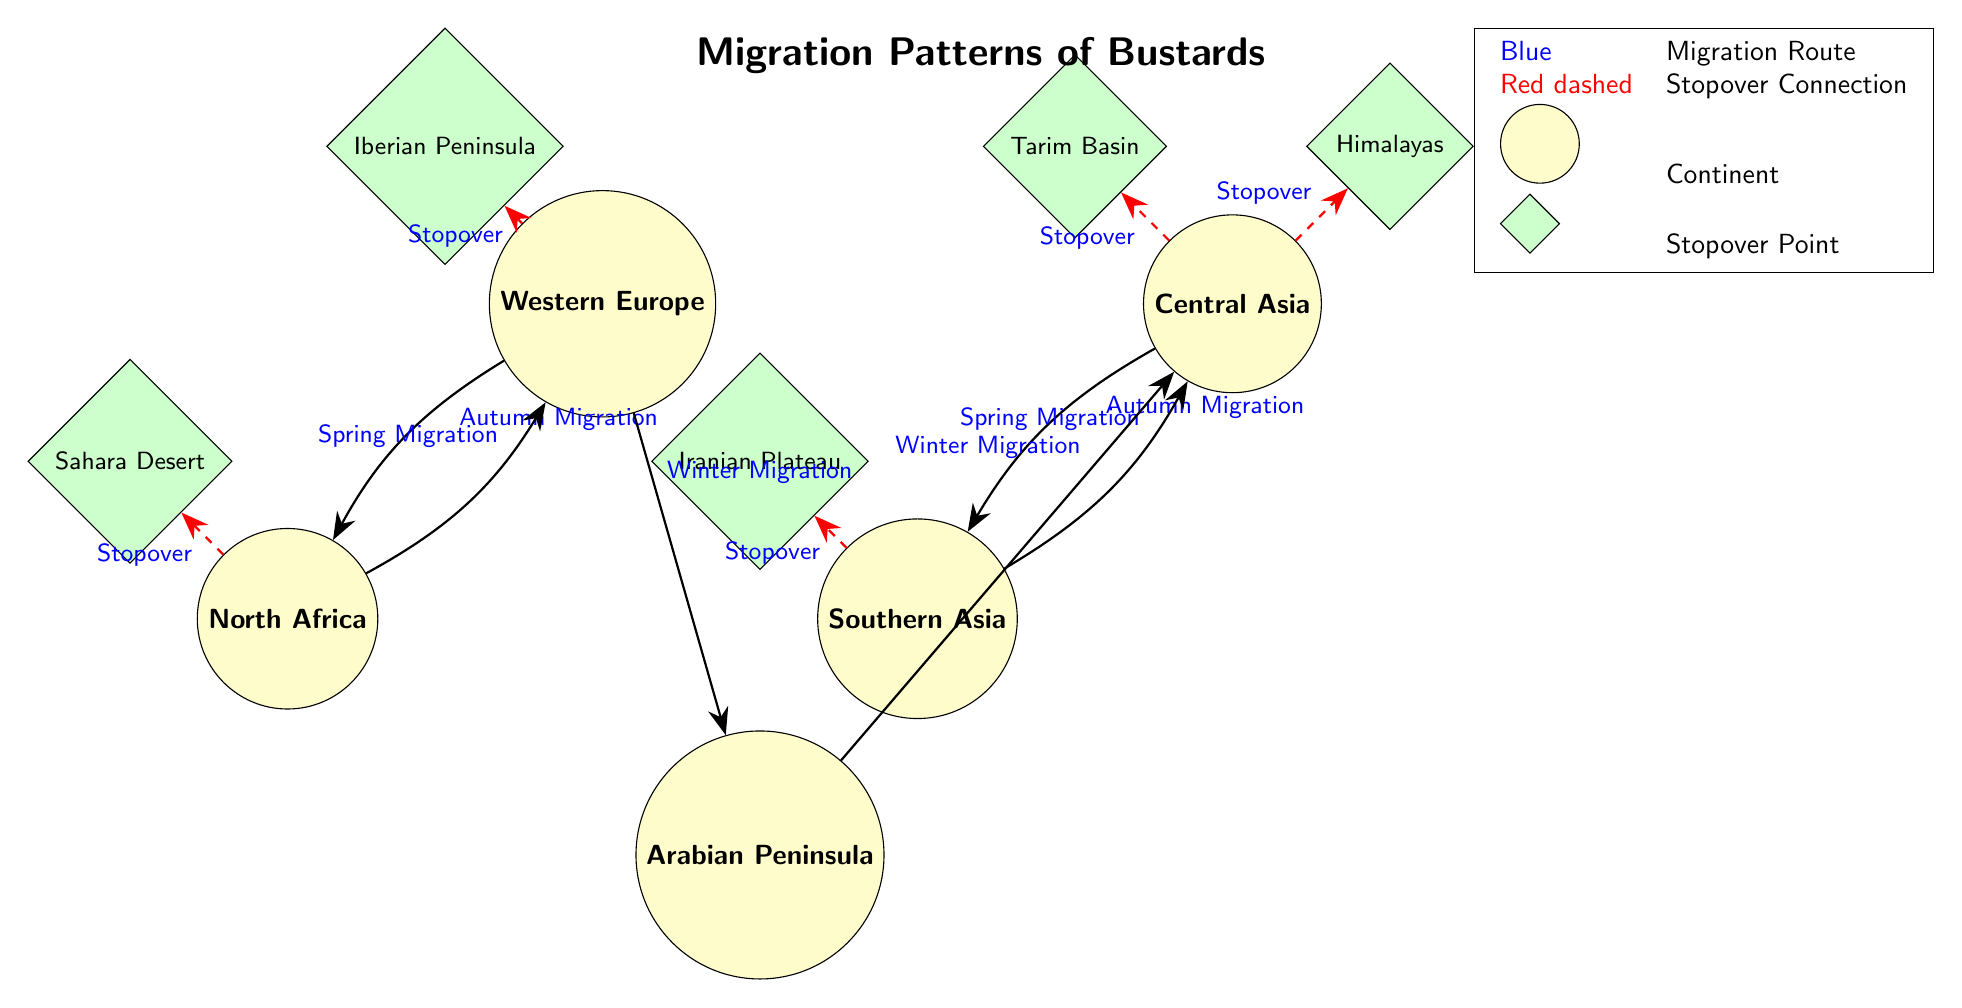What continents are involved in the migration patterns of bustards? According to the diagram, the continents involved in the migration patterns of bustards are Western Europe, North Africa, Central Asia, Southern Asia, and the Arabian Peninsula.
Answer: Western Europe, North Africa, Central Asia, Southern Asia, Arabian Peninsula How many stopover points are indicated in the diagram? The diagram displays a total of five stopover points, which are the Iberian Peninsula, Sahara Desert, Himalayas, Tarim Basin, and Iranian Plateau.
Answer: Five What migration type connects Western Europe and North Africa? The diagram indicates that the migration from Western Europe to North Africa occurs during the Autumn Migration, as noted in the edge labeled along the pathway between the two locations.
Answer: Autumn Migration Which stopover point is located to the north of the Arabian Peninsula? In the diagram, the Iranian Plateau is shown directly north of the Arabian Peninsula, as per its positioning in relation to other geographic markers.
Answer: Iranian Plateau Which two continents experience Spring Migration from Central Asia? From the diagram analysis, Central Asia experiences Spring Migration to two continents: Southern Asia and Western Europe. The connections are clearly shown as arrows leading towards each respective continent.
Answer: Southern Asia, Western Europe What color represents the migration route in the diagram? The color blue represents the migration routes in the diagram, as indicated by the line styles shown along the paths between the continents and stopover points.
Answer: Blue How are stopover connections visually distinguished from migration routes? Stopover connections in the diagram are represented by red dashed lines, while migration routes are shown with solid blue arrows. This distinct coloration helps to visually separate the two types of pathways.
Answer: Red dashed lines What is the relationship between Central Asia and Southern Asia in terms of migration? The relationship is that Central Asia and Southern Asia are connected during the Autumn Migration, where bustards migrate from Central Asia to Southern Asia. This is shown by the arrow indicating the migration path.
Answer: Autumn Migration Which stopover point is associated with Western Europe? The stopover point associated with Western Europe is the Iberian Peninsula, as shown by the dashed line connecting them in the diagram.
Answer: Iberian Peninsula 